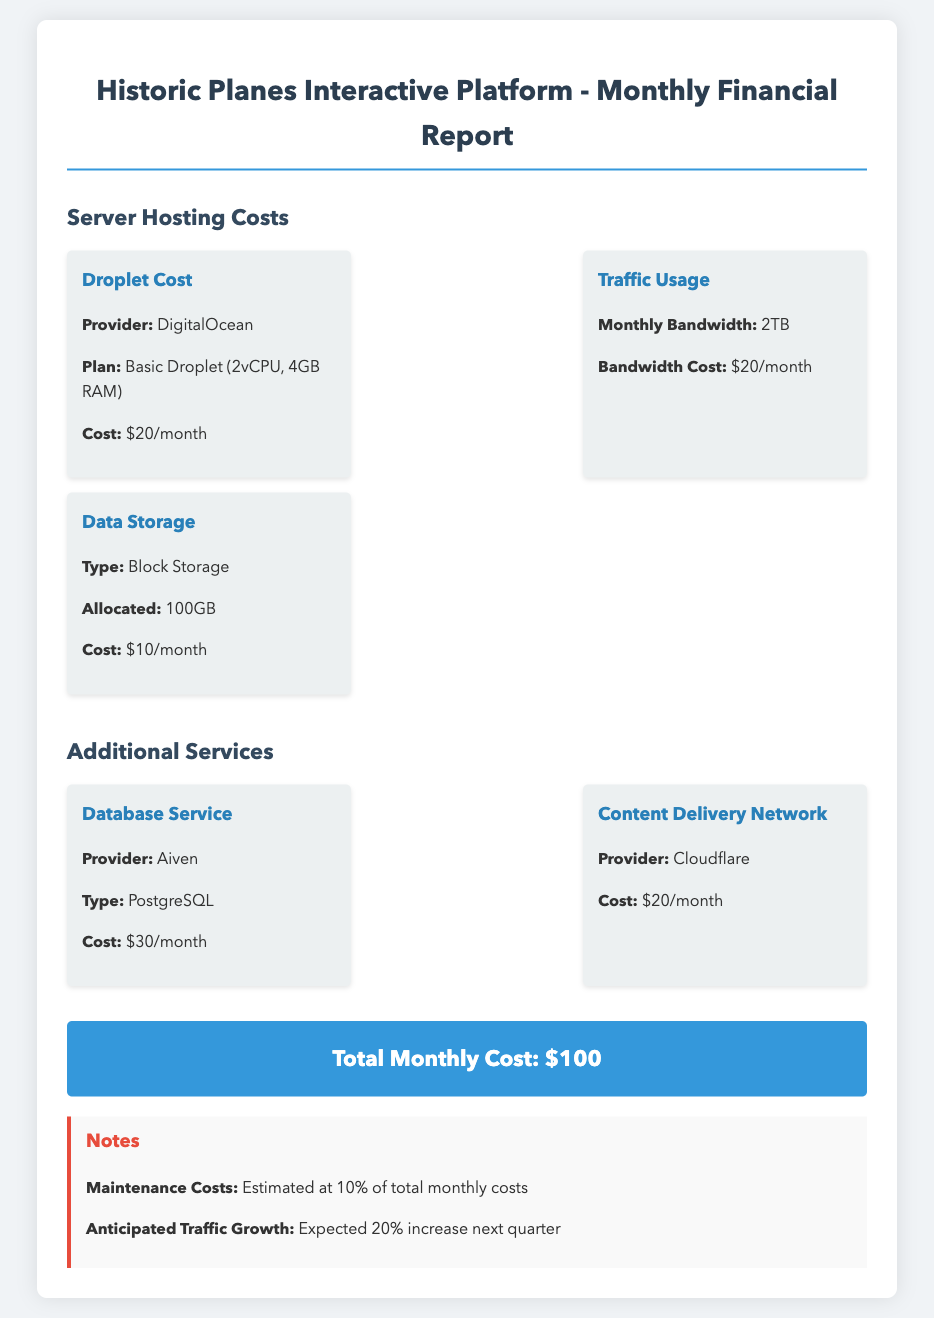what is the Droplet Cost? The Droplet Cost is mentioned as $20/month in the document.
Answer: $20/month what is the total monthly cost? The total monthly cost is provided in the document as $100.
Answer: $100 what is the type of data storage used? The type of data storage used is specified as Block Storage.
Answer: Block Storage how much is the cost for Traffic Usage? Traffic Usage cost is indicated as $20/month in the financial report.
Answer: $20/month what is the expected traffic growth next quarter? The document states that an anticipated traffic growth of 20% is expected next quarter.
Answer: 20% how many TB of monthly bandwidth is allocated? The document specifies that the monthly bandwidth is 2TB.
Answer: 2TB which provider offers the Database Service? The Database Service provider mentioned in the report is Aiven.
Answer: Aiven what percentage is estimated for maintenance costs? Maintenance costs are estimated at 10% of total monthly costs according to the notes.
Answer: 10% 